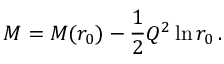<formula> <loc_0><loc_0><loc_500><loc_500>M = M ( r _ { 0 } ) - \frac { 1 } { 2 } Q ^ { 2 } \ln r _ { 0 } \, .</formula> 